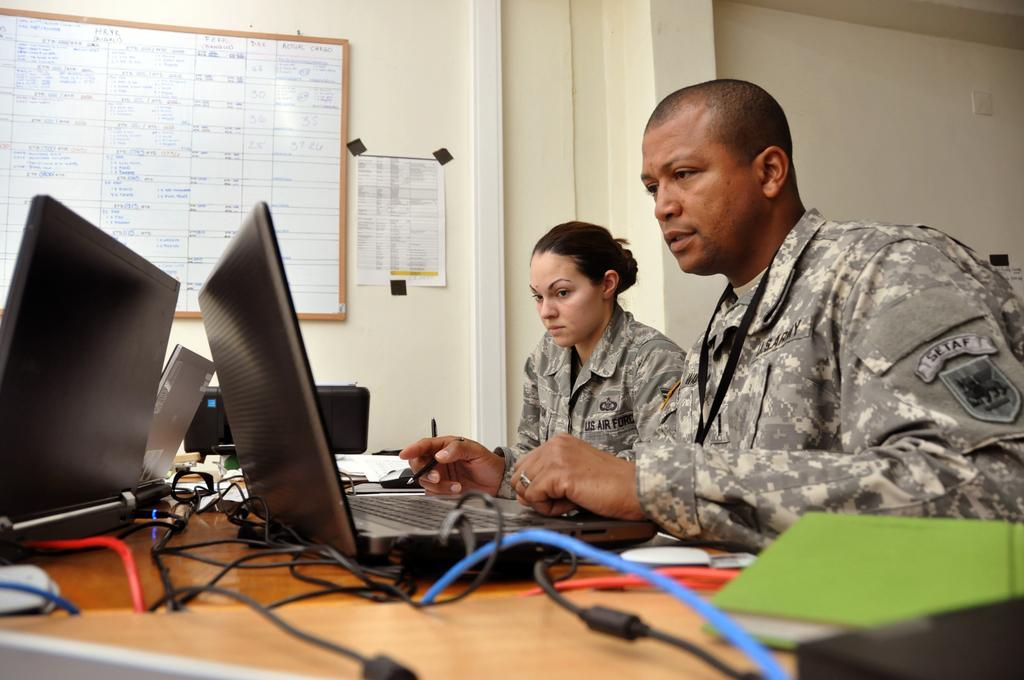<image>
Create a compact narrative representing the image presented. Two US Airforce personnel sitting at a desk looking at their laptop. 